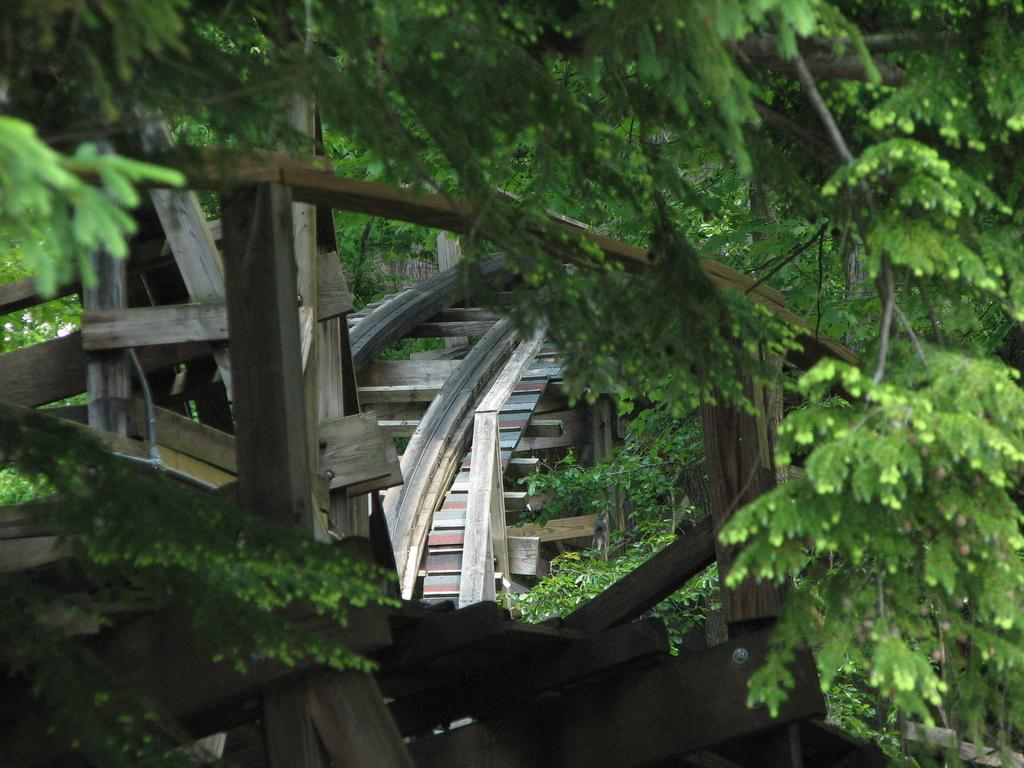What type of vegetation can be seen in the image? There are trees in the image. What is the name of the person who baked the pies in the image? There are no pies or people present in the image, so it is not possible to determine the name of the person who baked the pies. 